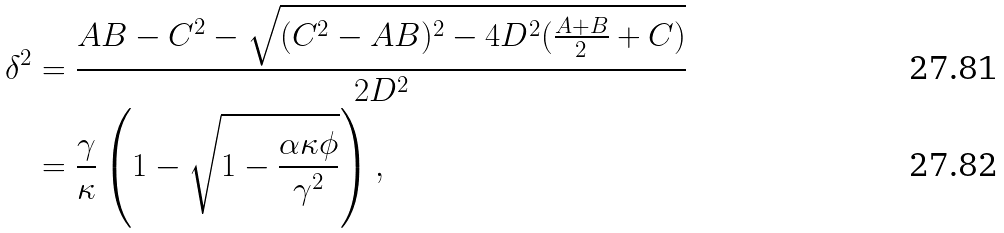Convert formula to latex. <formula><loc_0><loc_0><loc_500><loc_500>\delta ^ { 2 } & = \frac { A B - C ^ { 2 } - \sqrt { ( C ^ { 2 } - A B ) ^ { 2 } - 4 D ^ { 2 } ( \frac { A + B } { 2 } + C ) } } { 2 D ^ { 2 } } \\ & = \frac { \gamma } { \kappa } \left ( 1 - \sqrt { 1 - \frac { \alpha \kappa \phi } { \gamma ^ { 2 } } } \right ) ,</formula> 